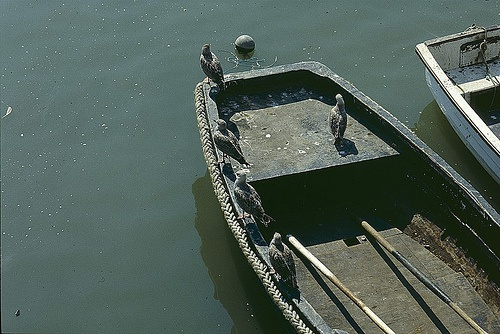Describe the objects in this image and their specific colors. I can see boat in gray, black, and darkgray tones, boat in gray, black, ivory, and darkgray tones, bird in gray, black, darkgray, and lightgray tones, bird in gray, black, darkgray, and lightgray tones, and bird in gray, black, darkgray, and lightgray tones in this image. 